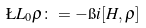<formula> <loc_0><loc_0><loc_500><loc_500>\L L _ { 0 } \rho \colon = - \i i [ H , \rho ]</formula> 